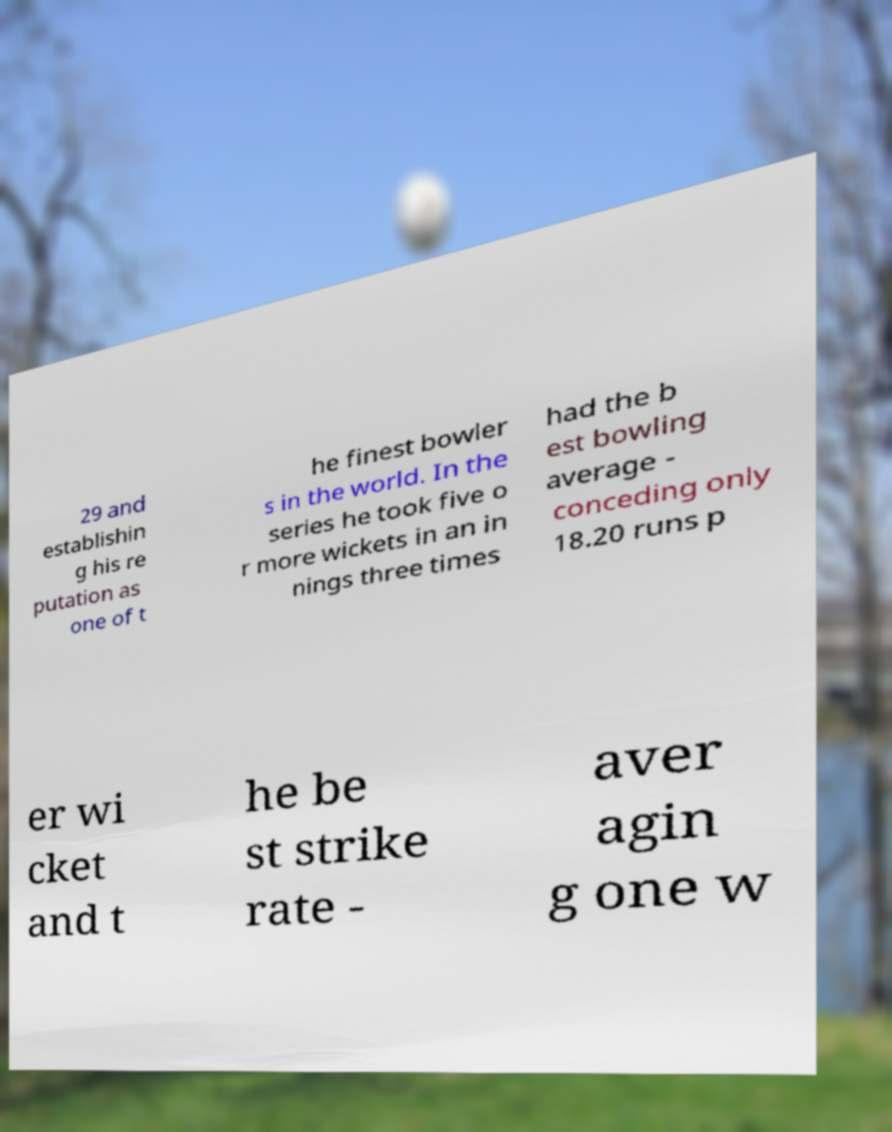For documentation purposes, I need the text within this image transcribed. Could you provide that? 29 and establishin g his re putation as one of t he finest bowler s in the world. In the series he took five o r more wickets in an in nings three times had the b est bowling average - conceding only 18.20 runs p er wi cket and t he be st strike rate - aver agin g one w 